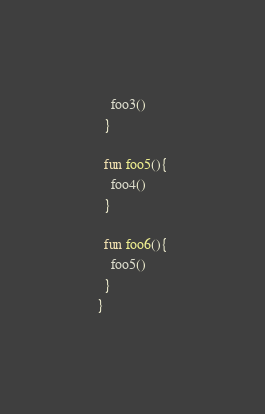Convert code to text. <code><loc_0><loc_0><loc_500><loc_500><_Kotlin_>    foo3()
  }

  fun foo5(){
    foo4()
  }

  fun foo6(){
    foo5()
  }
}</code> 